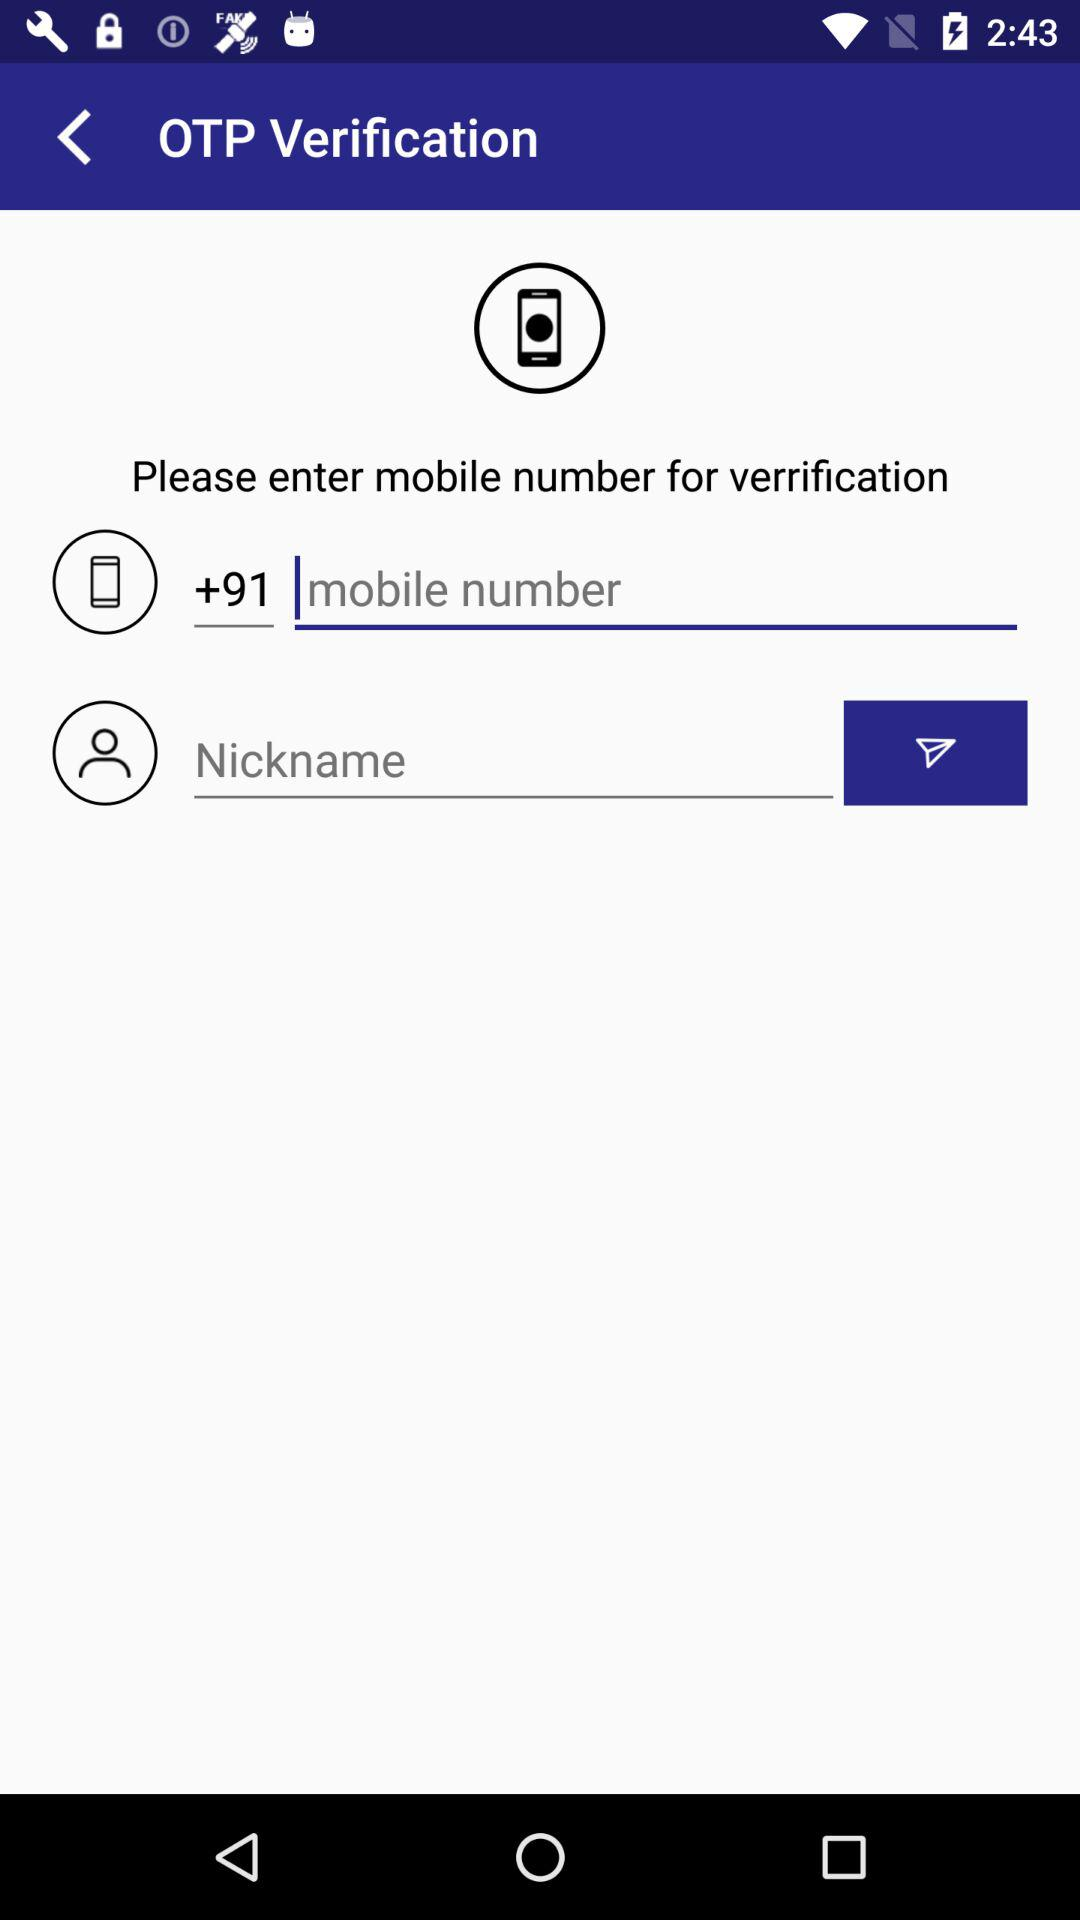How many input fields are there for entering the mobile number?
Answer the question using a single word or phrase. 2 